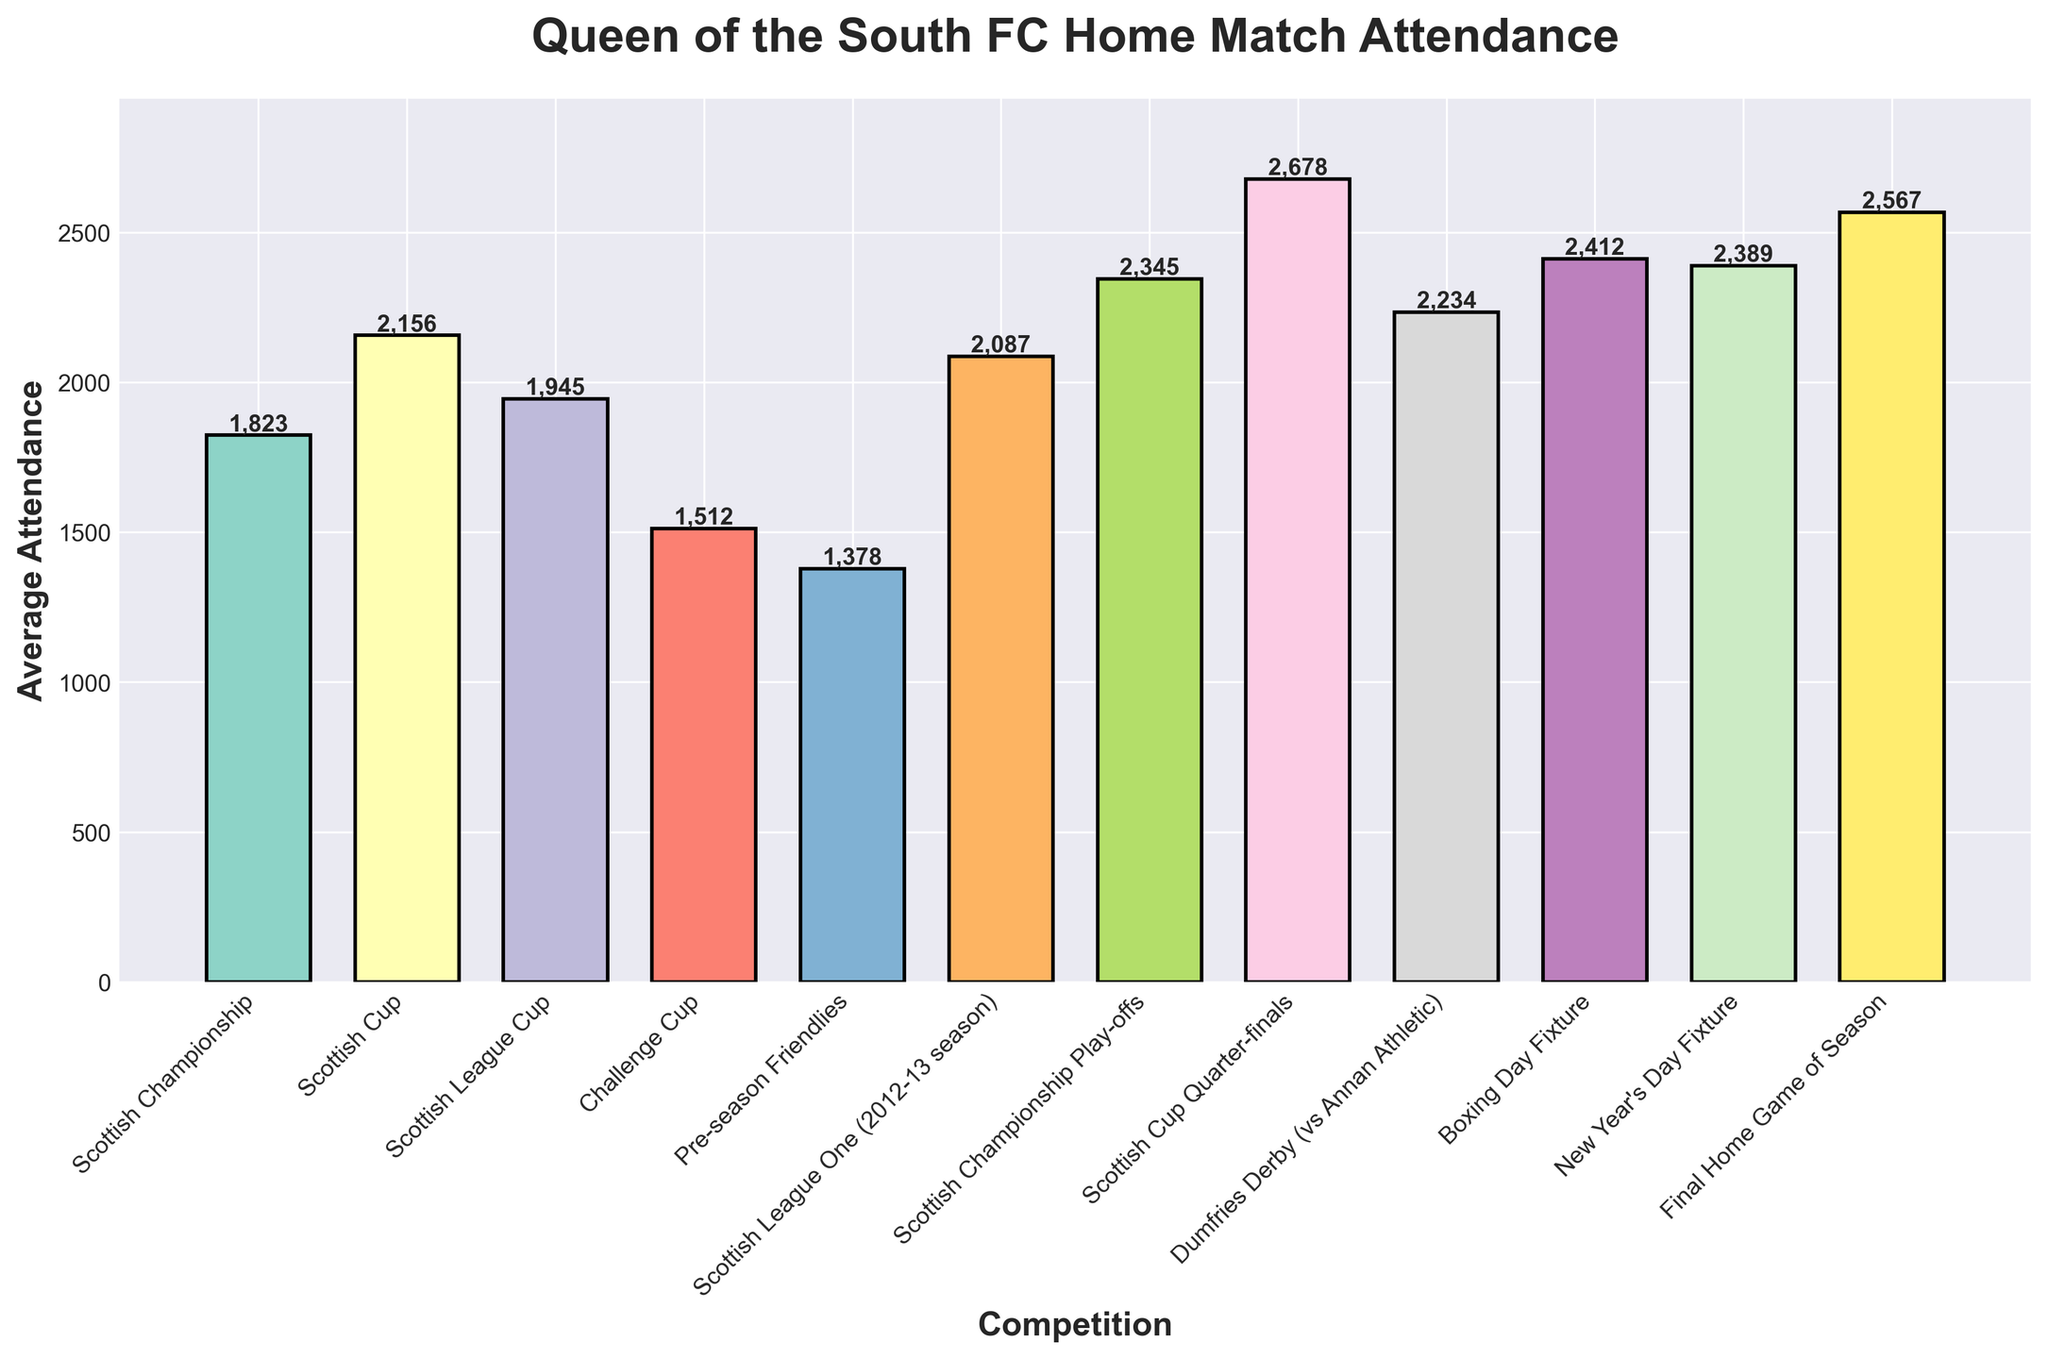Which competition had the highest average attendance? By observing the heights of the bars, the Scottish Cup Quarter-finals bar is the tallest. This indicates the highest average attendance.
Answer: Scottish Cup Quarter-finals Which competition had the lowest average attendance? By looking at the heights of the bars, the Pre-season Friendlies bar is the shortest. This shows the lowest average attendance.
Answer: Pre-season Friendlies How much higher is the average attendance of the Boxing Day Fixture compared to the Challenge Cup? First, identify the attendance for both competitions: 2412 for Boxing Day Fixture and 1512 for Challenge Cup. Then, calculate the difference: 2412 - 1512 = 900.
Answer: 900 What is the total average attendance for the New Year's Day Fixture and the Final Home Game of the Season? First, find the average attendance for each: 2389 for New Year's Day Fixture and 2567 for Final Home Game of the Season. Then, sum them: 2389 + 2567 = 4956.
Answer: 4956 Are there more competitions with average attendance greater than 2000 or less than 2000? Identify the competitions with attendance greater than 2000 (6 competitions) and less than 2000 (5 competitions). There are more competitions with average attendance greater than 2000.
Answer: Greater than 2000 Which competition had higher attendance: Scottish League One (2012-13 season) or Dumfries Derby (vs Annan Athletic)? Compare the heights of the bars for each competition. Scottish League One (2012-13 season) has an average attendance of 2087, and Dumfries Derby (vs Annan Athletic) has 2234, so Dumfries Derby is higher.
Answer: Dumfries Derby (vs Annan Athletic) What is the approximate average attendance for the Scottish League Cup? Observe the height of the bar representing the Scottish League Cup and read the number: 1945.
Answer: 1945 How does the average attendance of the Final Home Game of the Season compare to that of the Scottish Championship Play-offs? Identify the average attendance for both: 2567 for the Final Home Game of the Season and 2345 for the Scottish Championship Play-offs. The Final Home Game of the Season is higher.
Answer: Final Home Game of the Season 